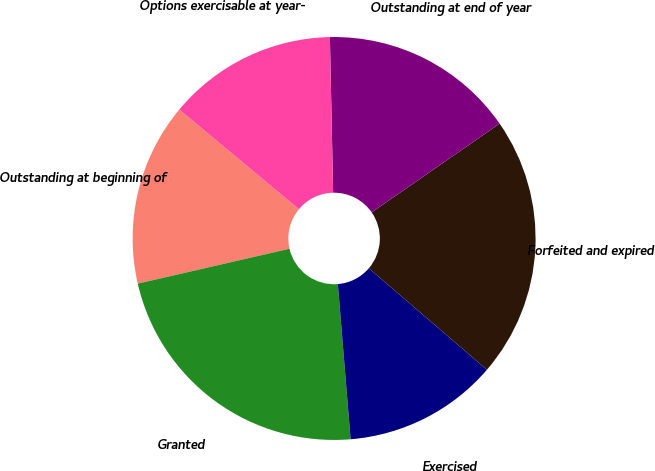<chart> <loc_0><loc_0><loc_500><loc_500><pie_chart><fcel>Outstanding at beginning of<fcel>Granted<fcel>Exercised<fcel>Forfeited and expired<fcel>Outstanding at end of year<fcel>Options exercisable at year-<nl><fcel>14.65%<fcel>22.71%<fcel>12.4%<fcel>20.95%<fcel>15.68%<fcel>13.62%<nl></chart> 